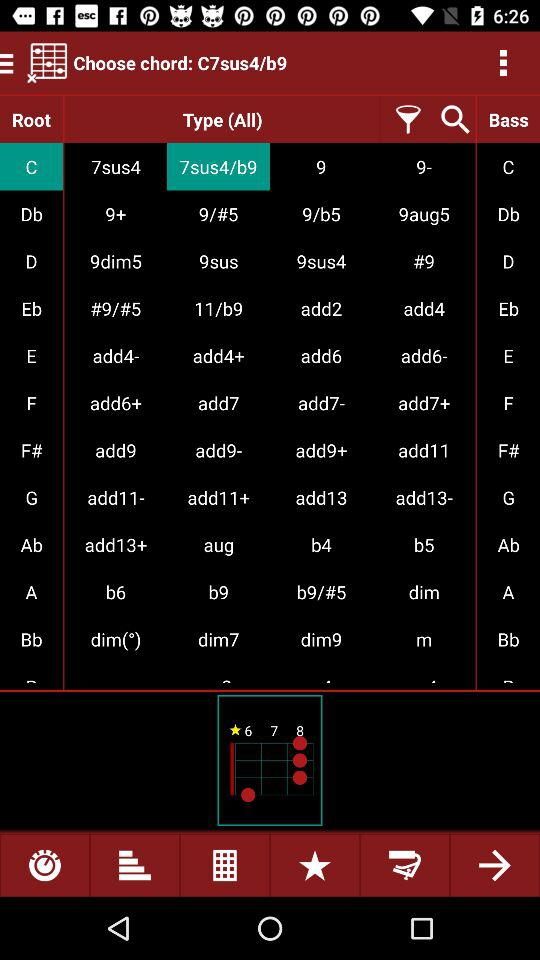What is the chosen chord? The chosen chord is "C7sus4/b9". 